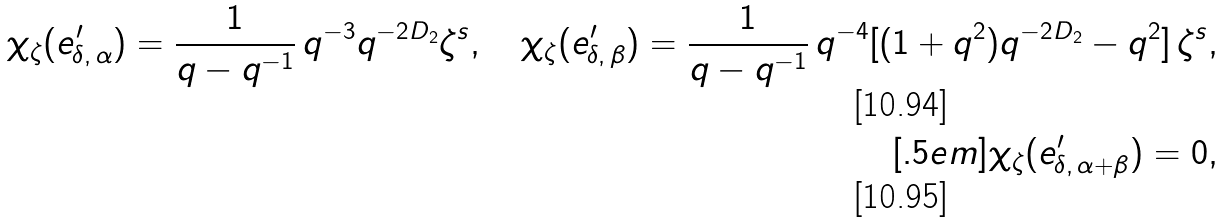<formula> <loc_0><loc_0><loc_500><loc_500>\chi _ { \zeta } ( e ^ { \prime } _ { \delta , \, \alpha } ) = \frac { 1 } { q - q ^ { - 1 } } \, q ^ { - 3 } q ^ { - 2 D _ { 2 } } \zeta ^ { s } , \quad \chi _ { \zeta } ( e ^ { \prime } _ { \delta , \, \beta } ) = \frac { 1 } { q - q ^ { - 1 } } \, q ^ { - 4 } [ ( 1 + q ^ { 2 } ) q ^ { - 2 D _ { 2 } } - q ^ { 2 } ] \, \zeta ^ { s } , \\ [ . 5 e m ] \chi _ { \zeta } ( e ^ { \prime } _ { \delta , \, \alpha + \beta } ) = 0 ,</formula> 